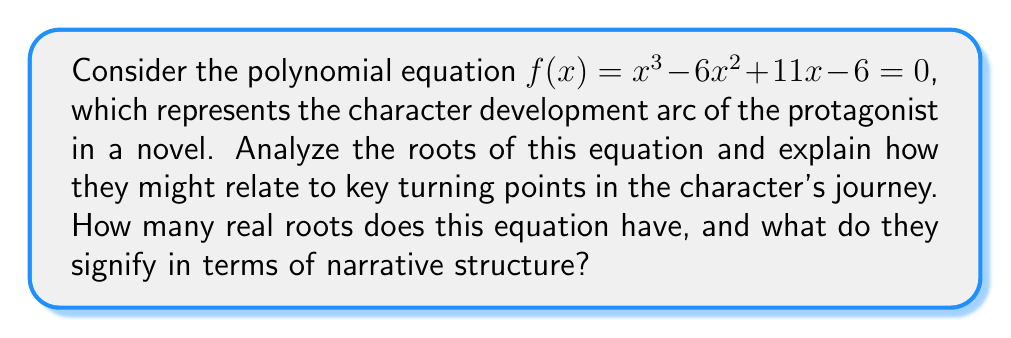Provide a solution to this math problem. To analyze the roots of the polynomial equation $f(x) = x^3 - 6x^2 + 11x - 6 = 0$, we'll follow these steps:

1) First, let's factor the polynomial:
   $f(x) = (x - 1)(x - 2)(x - 3) = 0$

2) The roots of the equation are the values of x that make $f(x) = 0$. From the factored form, we can see that the roots are:
   $x = 1, 2, \text{ and } 3$

3) This polynomial has three real roots, which in literary terms could represent three significant moments or turning points in the protagonist's character development.

4) In the context of narrative structure:
   - The root $x = 1$ might symbolize the initial conflict or call to action.
   - The root $x = 2$ could represent the midpoint of the story, where the character faces a major challenge.
   - The root $x = 3$ might signify the climax or resolution of the character's arc.

5) The fact that the roots are evenly spaced (1, 2, 3) could suggest a well-paced narrative with equally significant turning points.

6) The polynomial's shape (cubic) mirrors the classic three-act structure in literature: setup, confrontation, and resolution.

This mathematical approach provides a unique lens through which to view character development, offering a quantitative complement to traditional qualitative analysis of narrative structure.
Answer: 3 real roots; representing beginning, middle, and end of character arc 